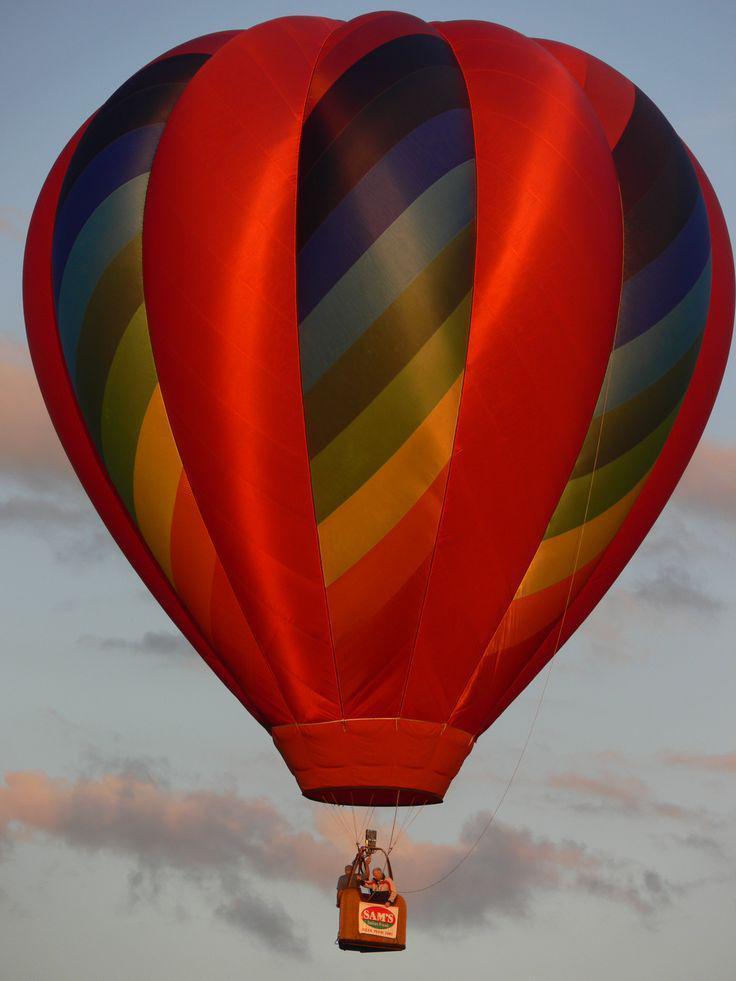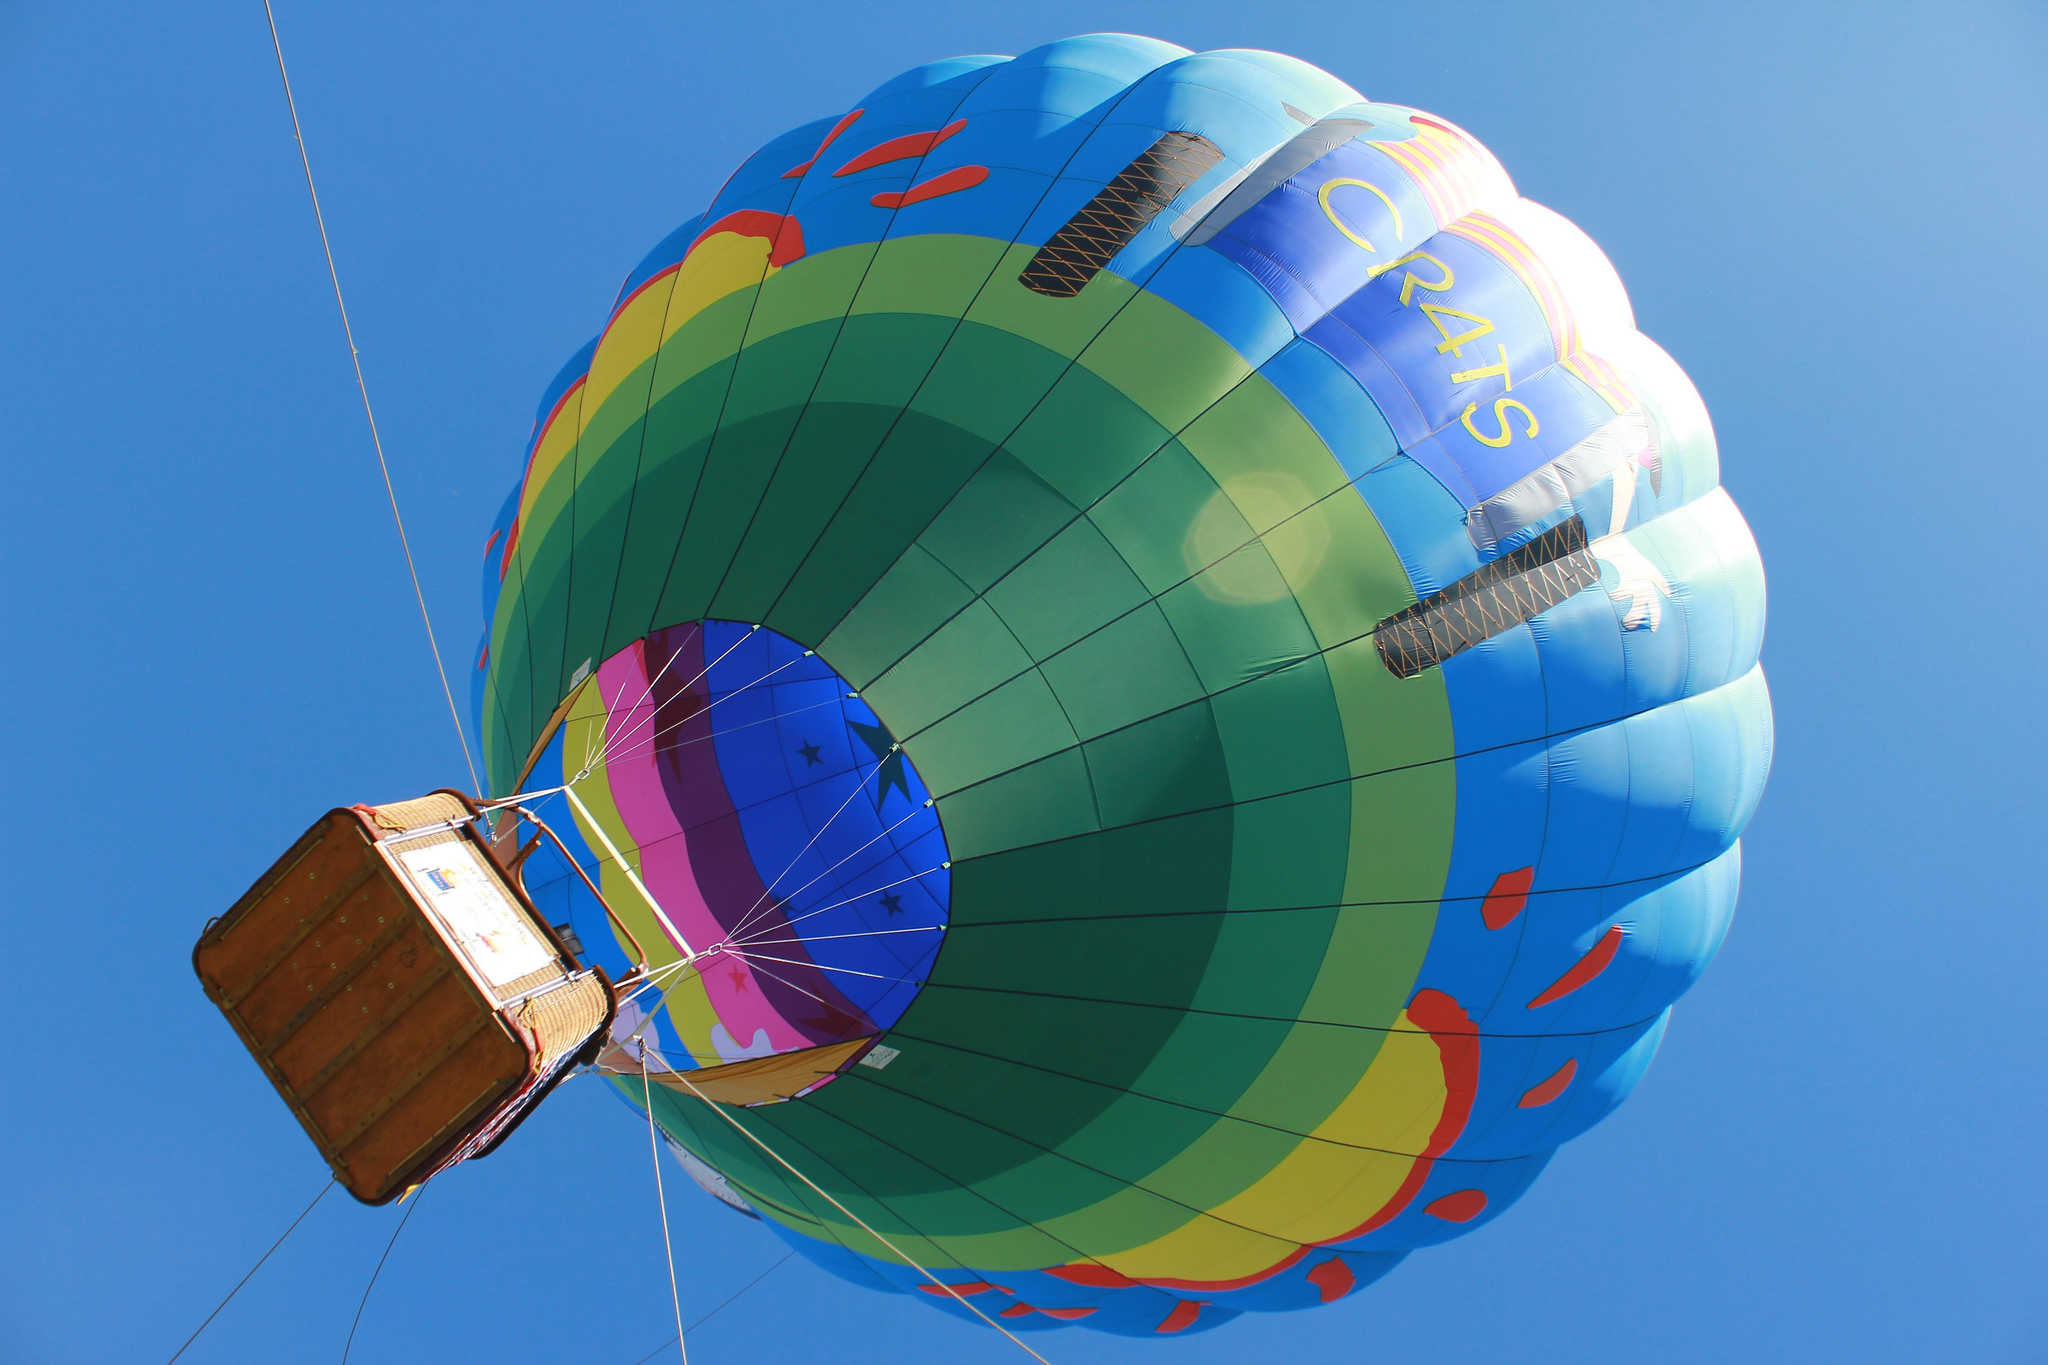The first image is the image on the left, the second image is the image on the right. Given the left and right images, does the statement "A total of two hot air balloons with wicker baskets attached below are shown against the sky." hold true? Answer yes or no. Yes. 